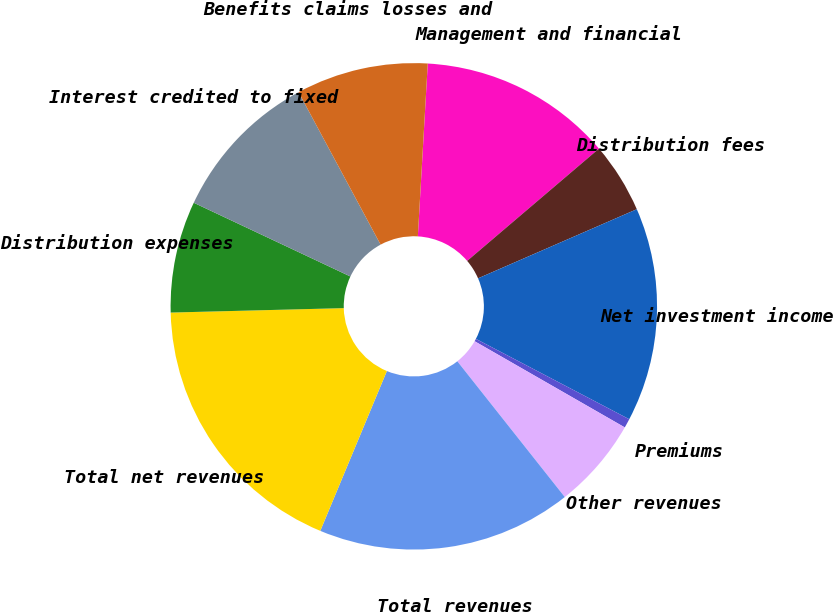Convert chart to OTSL. <chart><loc_0><loc_0><loc_500><loc_500><pie_chart><fcel>Management and financial<fcel>Distribution fees<fcel>Net investment income<fcel>Premiums<fcel>Other revenues<fcel>Total revenues<fcel>Total net revenues<fcel>Distribution expenses<fcel>Interest credited to fixed<fcel>Benefits claims losses and<nl><fcel>12.86%<fcel>4.69%<fcel>14.22%<fcel>0.61%<fcel>6.05%<fcel>16.94%<fcel>18.31%<fcel>7.41%<fcel>10.14%<fcel>8.77%<nl></chart> 